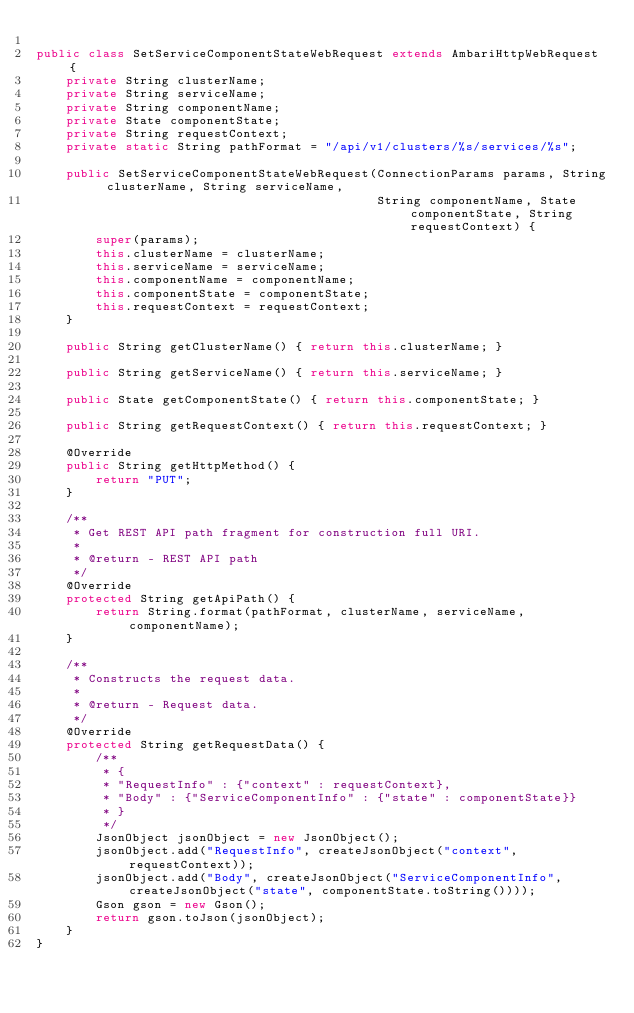<code> <loc_0><loc_0><loc_500><loc_500><_Java_>
public class SetServiceComponentStateWebRequest extends AmbariHttpWebRequest {
    private String clusterName;
    private String serviceName;
    private String componentName;
    private State componentState;
    private String requestContext;
    private static String pathFormat = "/api/v1/clusters/%s/services/%s";

    public SetServiceComponentStateWebRequest(ConnectionParams params, String clusterName, String serviceName,
                                              String componentName, State componentState, String requestContext) {
        super(params);
        this.clusterName = clusterName;
        this.serviceName = serviceName;
        this.componentName = componentName;
        this.componentState = componentState;
        this.requestContext = requestContext;
    }

    public String getClusterName() { return this.clusterName; }

    public String getServiceName() { return this.serviceName; }

    public State getComponentState() { return this.componentState; }

    public String getRequestContext() { return this.requestContext; }

    @Override
    public String getHttpMethod() {
        return "PUT";
    }

    /**
     * Get REST API path fragment for construction full URI.
     *
     * @return - REST API path
     */
    @Override
    protected String getApiPath() {
        return String.format(pathFormat, clusterName, serviceName, componentName);
    }

    /**
     * Constructs the request data.
     *
     * @return - Request data.
     */
    @Override
    protected String getRequestData() {
        /**
         * {
         * "RequestInfo" : {"context" : requestContext},
         * "Body" : {"ServiceComponentInfo" : {"state" : componentState}}
         * }
         */
        JsonObject jsonObject = new JsonObject();
        jsonObject.add("RequestInfo", createJsonObject("context", requestContext));
        jsonObject.add("Body", createJsonObject("ServiceComponentInfo", createJsonObject("state", componentState.toString())));
        Gson gson = new Gson();
        return gson.toJson(jsonObject);
    }
}
</code> 